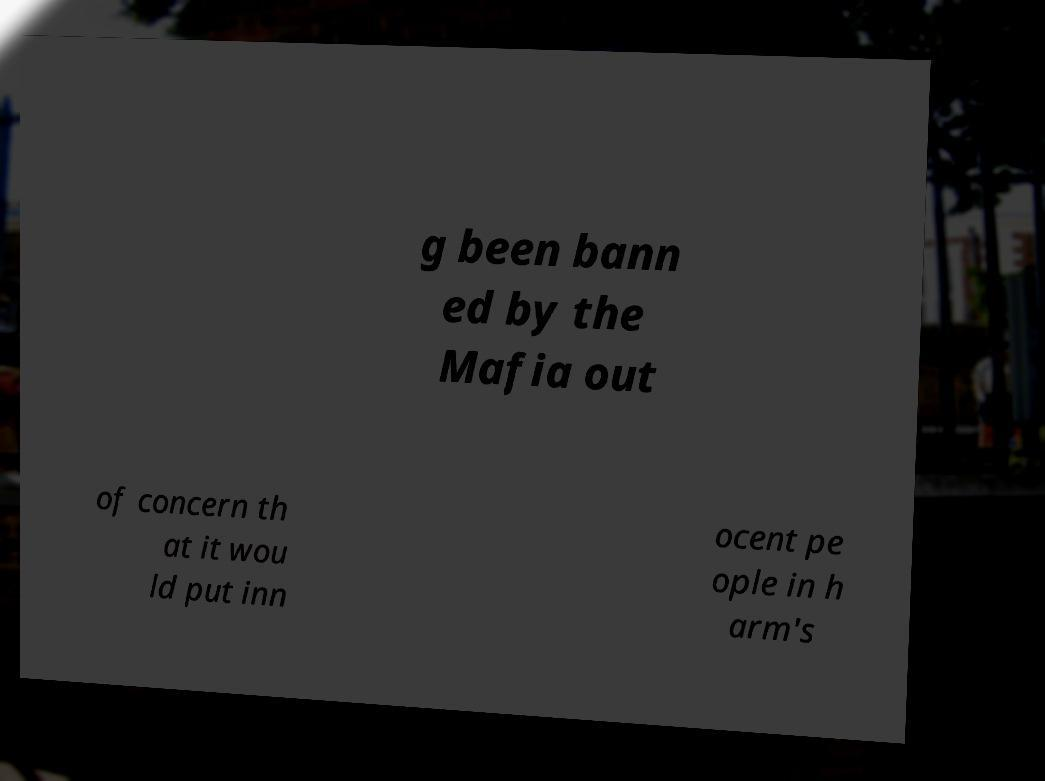Please identify and transcribe the text found in this image. g been bann ed by the Mafia out of concern th at it wou ld put inn ocent pe ople in h arm's 